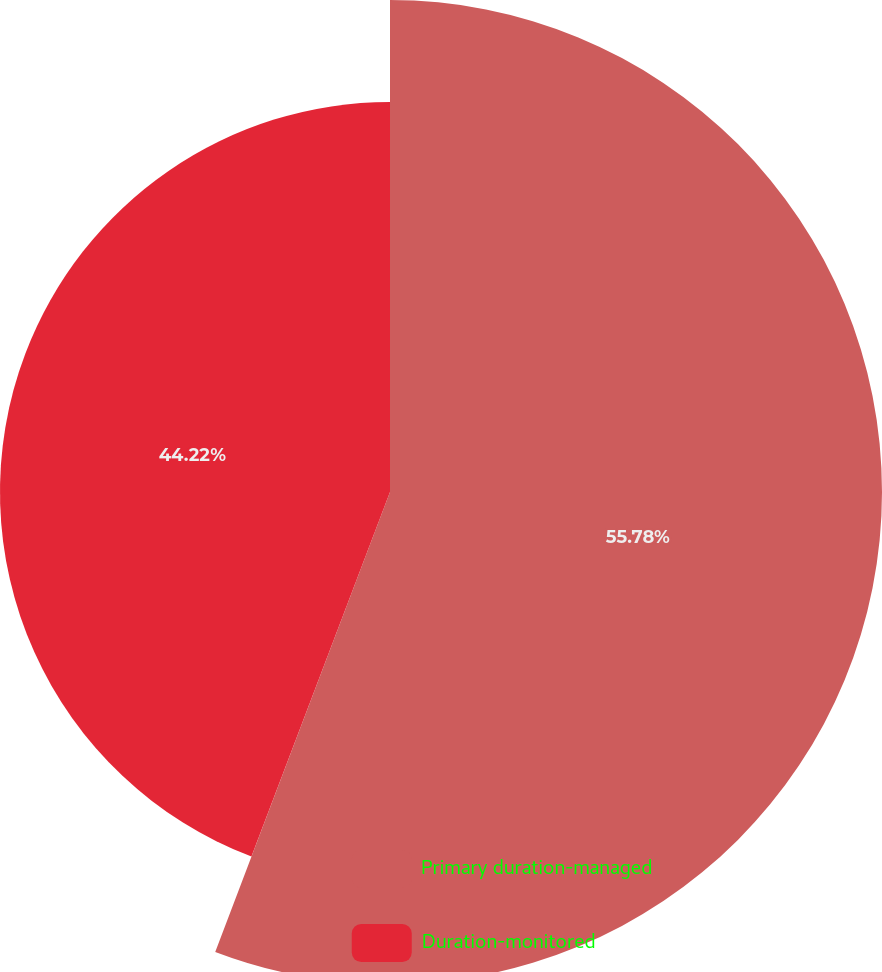Convert chart to OTSL. <chart><loc_0><loc_0><loc_500><loc_500><pie_chart><fcel>Primary duration-managed<fcel>Duration-monitored<nl><fcel>55.78%<fcel>44.22%<nl></chart> 